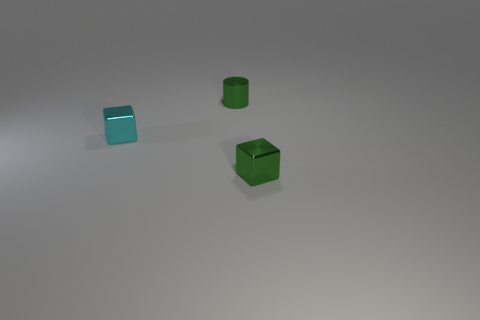Add 1 big cyan rubber blocks. How many objects exist? 4 Add 1 tiny metal cubes. How many tiny metal cubes are left? 3 Add 2 shiny blocks. How many shiny blocks exist? 4 Subtract 1 green blocks. How many objects are left? 2 Subtract all cylinders. How many objects are left? 2 Subtract all purple cylinders. Subtract all gray balls. How many cylinders are left? 1 Subtract all green metallic things. Subtract all green metal blocks. How many objects are left? 0 